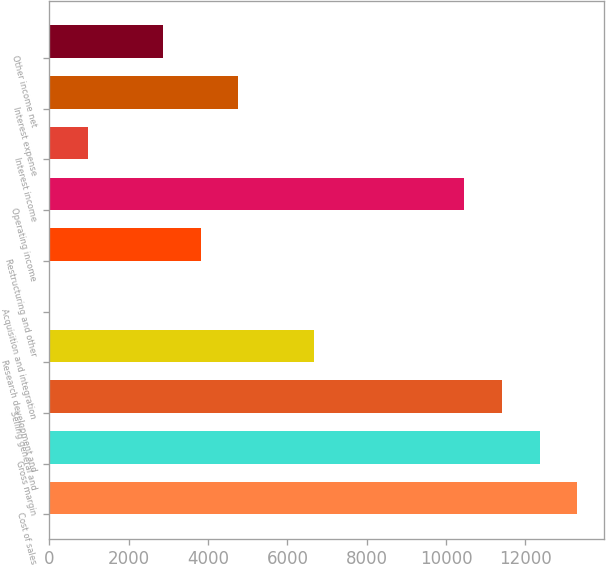<chart> <loc_0><loc_0><loc_500><loc_500><bar_chart><fcel>Cost of sales<fcel>Gross margin<fcel>Selling general and<fcel>Research development and<fcel>Acquisition and integration<fcel>Restructuring and other<fcel>Operating income<fcel>Interest income<fcel>Interest expense<fcel>Other income net<nl><fcel>13302.2<fcel>12353.4<fcel>11404.6<fcel>6660.6<fcel>19<fcel>3814.2<fcel>10455.8<fcel>967.8<fcel>4763<fcel>2865.4<nl></chart> 